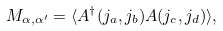<formula> <loc_0><loc_0><loc_500><loc_500>M _ { \alpha , \alpha ^ { \prime } } = \langle A ^ { \dagger } ( j _ { a } , j _ { b } ) A ( j _ { c } , j _ { d } ) \rangle ,</formula> 